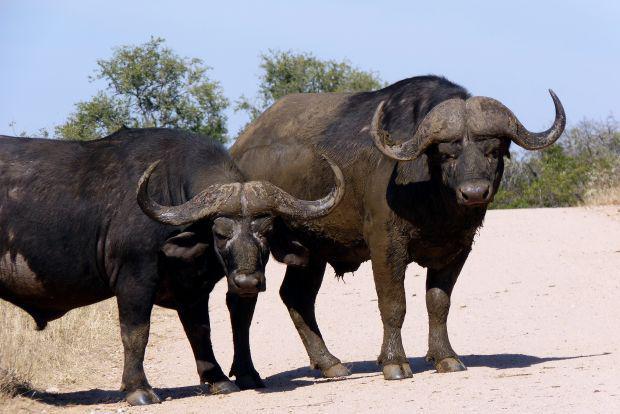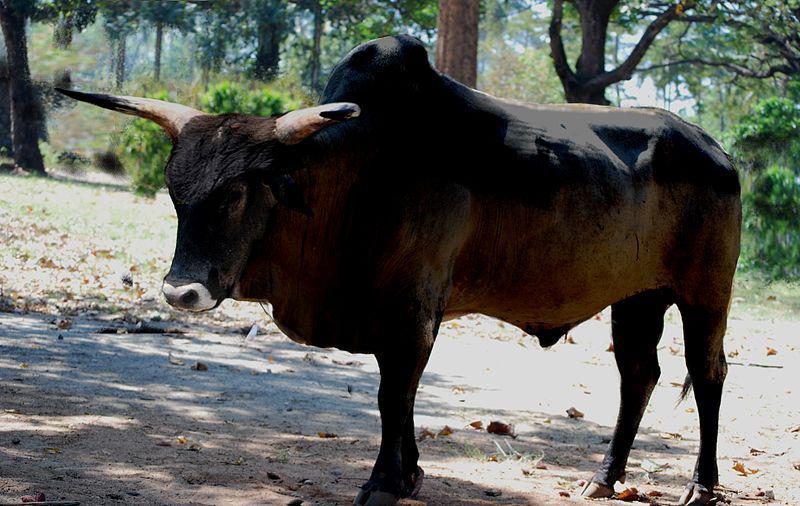The first image is the image on the left, the second image is the image on the right. For the images shown, is this caption "A calf is being fed by it's mother" true? Answer yes or no. No. 